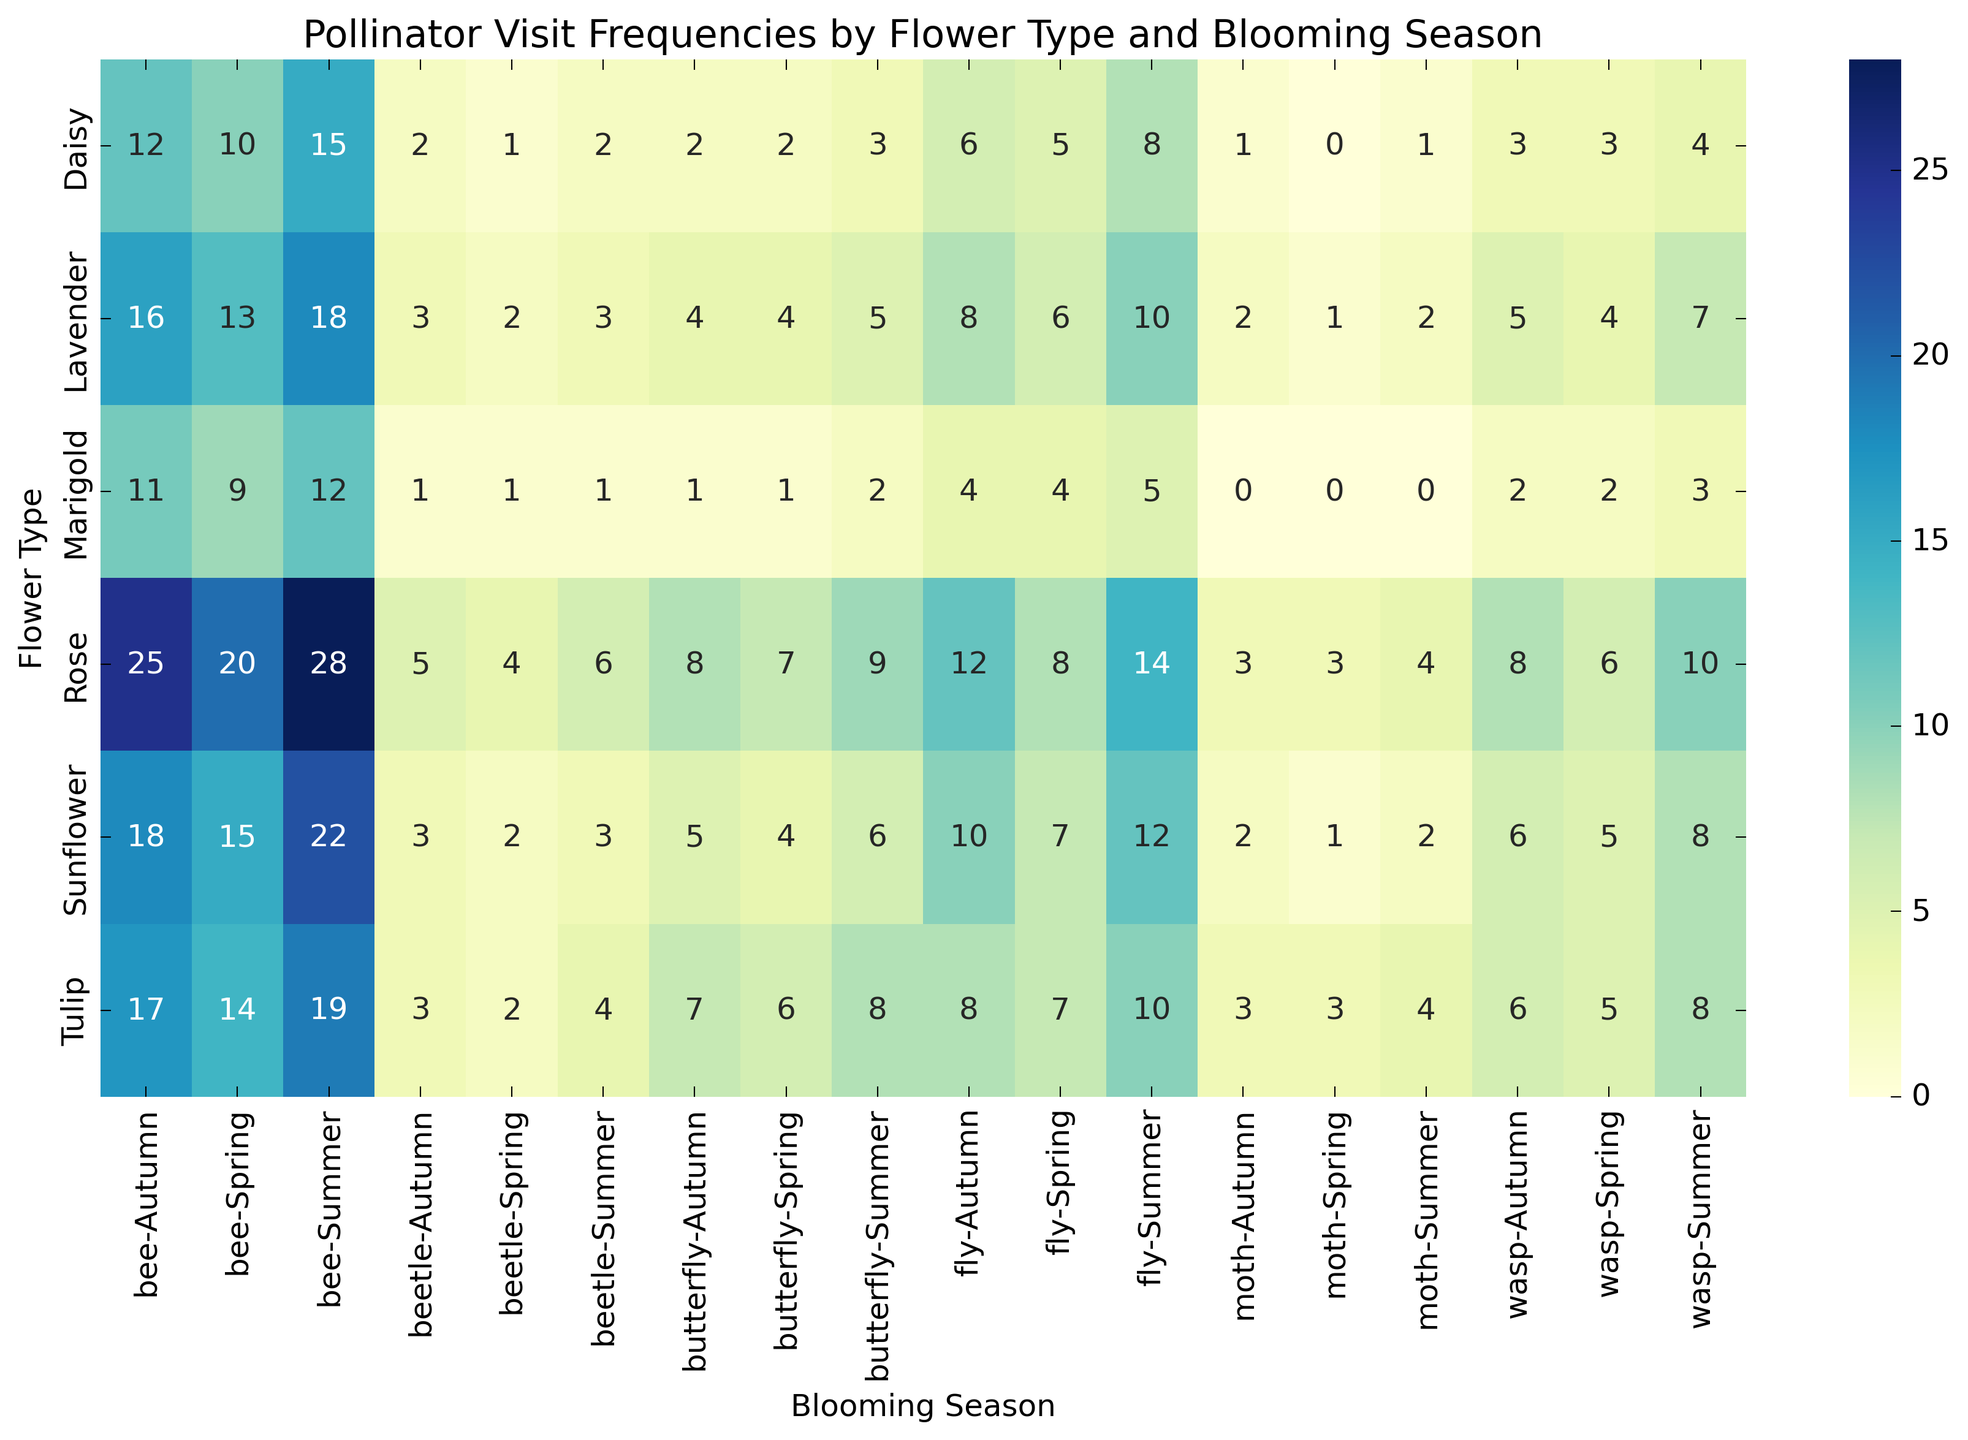Could you tell which blooming season has the highest number of bee visits for Sunflower? The heatmap shows the highest frequency of bee visits in different colors for each blooming season. For Sunflower, the highest number of bee visits is recorded in Summer.
Answer: Summer Which flower has the most pollinator visits in Spring? Look at the annotations on the heatmap for each flower type in Spring and sum up the visits for all pollinators (bee, wasp, fly, beetle, butterfly, and moth). Rose has the highest total pollinator visits in Spring.
Answer: Rose How do the total pollinator visits for Tulip in Autumn compare to Daisy in Summer? Sum the pollinator visits for Tulip in Autumn (17 + 6 + 8 + 3 + 7 + 3 = 44). Do the same for Daisy in Summer (15 + 4 + 8 + 2 + 3 + 1 = 33). Tulip has more pollinator visits in Autumn compared to Daisy in Summer.
Answer: Tulip in Autumn What's the difference in wasp visits between Marigold in Spring and Summer? Check the heatmap for Marigold and find the wasp visits in Spring (2) and Summer (3). Calculate the difference (3 - 2 = 1).
Answer: 1 Which flower type tends to attract the most butterflies in Summer? Look at the heatmap for butterfly visits in Summer across all flower types. Rose has the highest butterfly visits in Summer (9).
Answer: Rose What is the total number of beetle visits for all flowers in Autumn? Sum the beetle visits in Autumn for each flower type: Sunflower (3), Rose (5), Daisy (2), Lavender (3), Marigold (1), Tulip (3). The total is (3 + 5 + 2 + 3 + 1 + 3 = 17).
Answer: 17 Compare the moth visits between Sunflower and Rose in Spring. Check the heatmap for moth visits in Spring for both Sunflower and Rose. Sunflower has 1 moth visit, and Rose has 3. Rose has more moth visits than Sunflower in Spring.
Answer: Rose What is the average number of pollinator visits for Lavender across all seasons? Sum the total visits across all seasons for Lavender (Spring: 13+4+6+2+4+1 = 30, Summer: 18+7+10+3+5+2 = 45, Autumn: 16+5+8+3+4+2 = 38). Calculate the average ((30 + 45 + 38) / 3 = 113/3 ≈ 37.67).
Answer: 37.67 